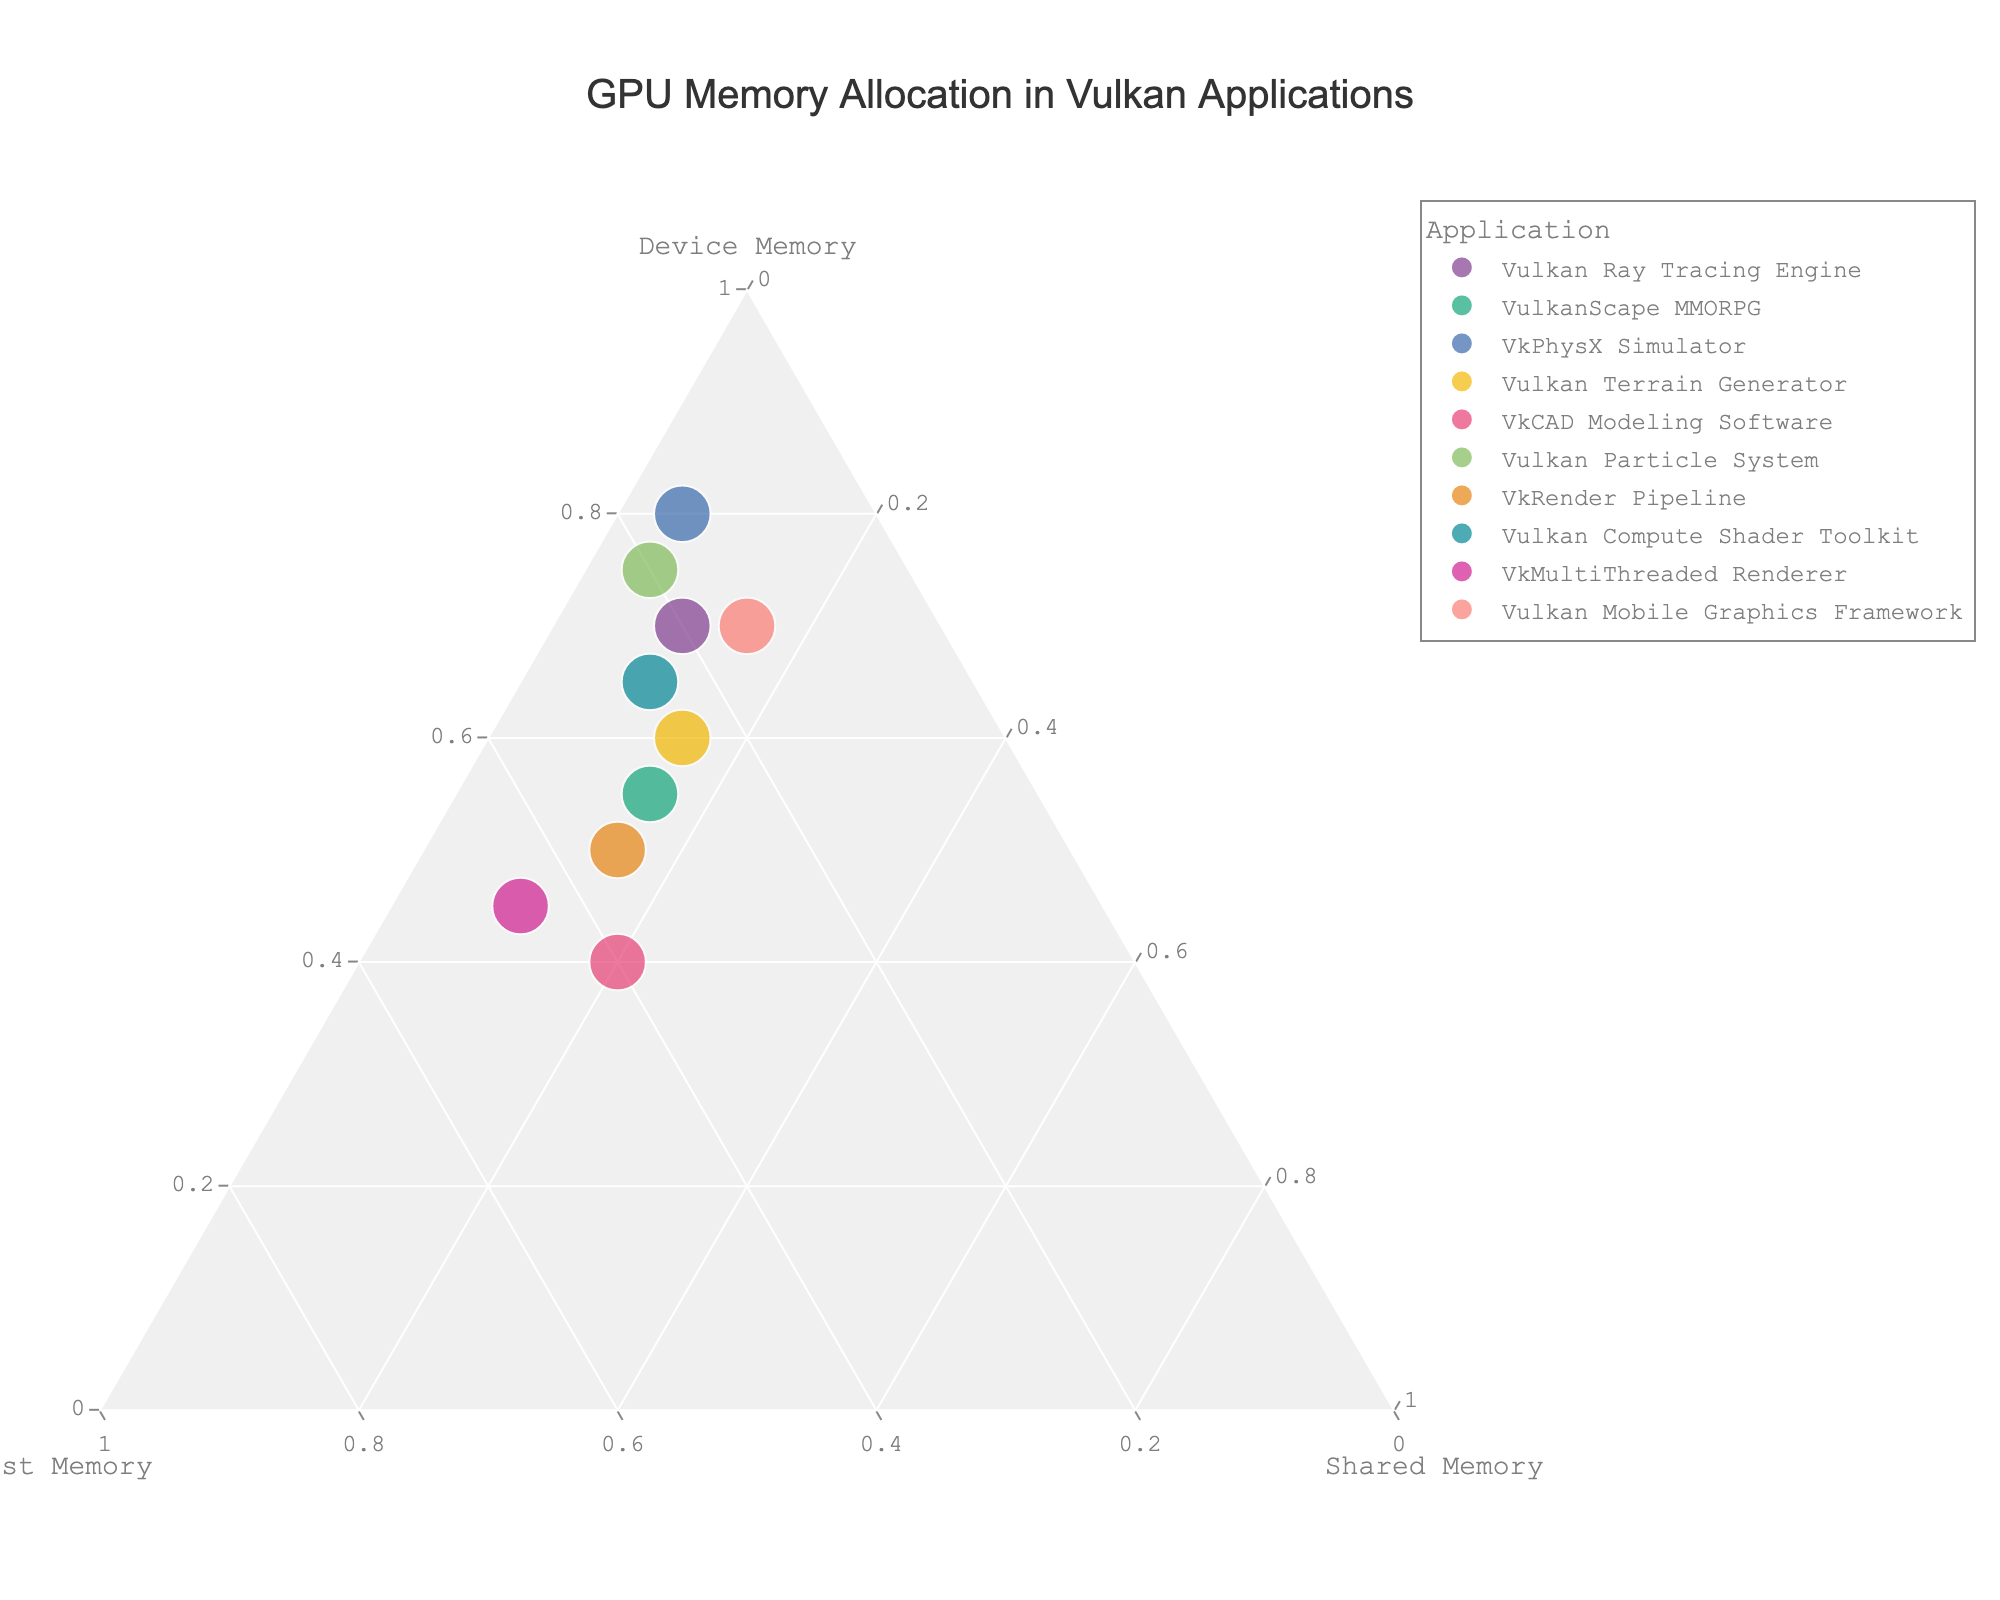How many applications are represented in the ternary plot? Count the number of distinct points or hover names shown in the plot. The plot visualizes 10 applications, each represented by a point.
Answer: 10 Which application allocates the highest percentage of shared memory? Observe the point closest to the Shared Memory axis. "VkCAD Modeling Software" allocates 20% shared memory, which is the highest among all applications.
Answer: VkCAD Modeling Software Which application has the most balanced allocation between device and host memory? Look for the point closest to the midpoint between the Device Memory and Host Memory axes. "VkMultiThreaded Renderer" has 45% allocated to both, making it the most balanced.
Answer: VkMultiThreaded Renderer What percentage of device memory does the Vulkan Ray Tracing Engine allocate? Find the point for "Vulkan Ray Tracing Engine" and read its coordinate on the Device Memory axis. It allocates 70% device memory.
Answer: 70% Which two applications have the same percentage allocation for shared memory? Identify points on the Shared Memory axis that share the same value. Both "Vulkan Ray Tracing Engine" and "Vulkan Mobile Graphics Framework" allocate 15% to shared memory.
Answer: Vulkan Ray Tracing Engine, Vulkan Mobile Graphics Framework What's the difference in device memory allocation between Vulkan Terrain Generator and VkRender Pipeline? Subtract the device memory percentage of "VkRender Pipeline" from that of "Vulkan Terrain Generator". 60% (Vulkan Terrain Generator) - 50% (VkRender Pipeline) = 10%.
Answer: 10% Which application allocates the highest percentage to device memory? Identify the point closest to the Device Memory apex. "VkPhysX Simulator" allocates 80% device memory, the highest.
Answer: VkPhysX Simulator If we average the host memory allocation across all applications, what value do we get? Add up all the host memory percentages, then divide by the number of applications. (20 + 30 + 15 + 25 + 40 + 20 + 35 + 25 + 45 + 15) / 10 = 27%
Answer: 27% How does the host memory allocation of VulkanScape MMORPG compare to VkRender Pipeline? Observe the host memory percentages for both and compare. "VulkanScape MMORPG" allocates 30%, while "VkRender Pipeline" allocates 35%, making VkRender Pipeline higher.
Answer: VkRender Pipeline Which application has the least total combined allocation for host and shared memory? Sum the host and shared memory percentages for each application and find the lowest total. "VkPhysX Simulator" has the lowest total: 15% (host) + 5% (shared) = 20%.
Answer: VkPhysX Simulator 